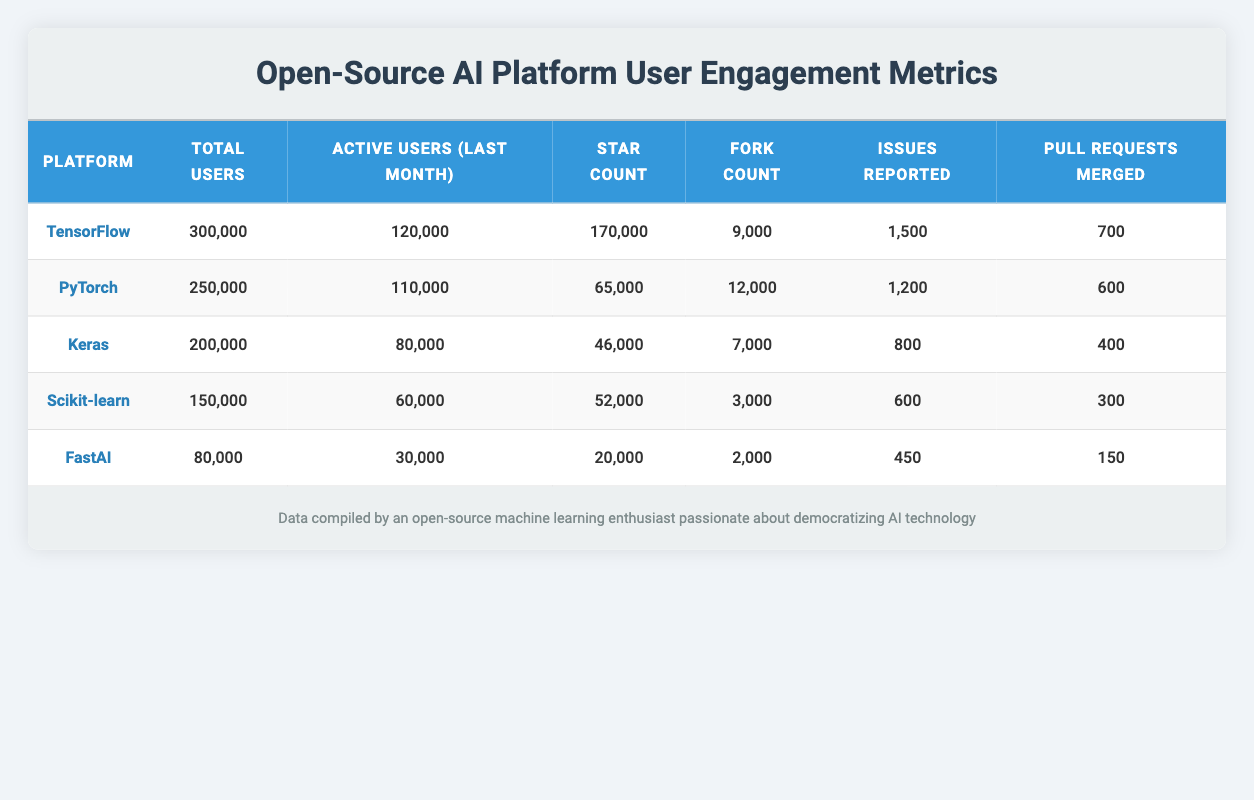What is the total number of users for Keras? According to the table, the row for Keras displays the total users as 200,000.
Answer: 200,000 Which platform has the highest star count? The table shows TensorFlow with a star count of 170,000, which is higher than other platforms, making it the highest.
Answer: TensorFlow What is the difference in active users between PyTorch and Scikit-learn? PyTorch has 110,000 active users, while Scikit-learn has 60,000. The difference is calculated as 110,000 - 60,000 = 50,000.
Answer: 50,000 How many pull requests merged are reported for FastAI? The table indicates that FastAI has 150 pull requests merged, mentioned directly in its row.
Answer: 150 Does Keras have more total users than PyTorch? The total users for Keras are 200,000, while for PyTorch, it is 250,000. Since 200,000 is less than 250,000, the answer is no.
Answer: No What is the average number of issues reported across all platforms? To find the average, first sum the issues reported: 1500 + 1200 + 800 + 600 + 450 = 3750. Then divide this total by the number of platforms (5), so 3750 / 5 = 750.
Answer: 750 How many platforms have more than 100,000 total users? The platforms TensorFlow (300,000), PyTorch (250,000), and Keras (200,000) have more than 100,000 total users. Thus, there are three platforms meeting this criterion.
Answer: 3 What is the ratio of active users to total users for Scikit-learn? For Scikit-learn, the active users are 60,000, and total users are 150,000. The ratio is 60,000 / 150,000, which simplifies to 2 / 5 or 0.4.
Answer: 0.4 Which platform reports the lowest number of issues? Looking at the issues reported, FastAI has the lowest count at 450 compared to all other platforms mentioned in the table.
Answer: FastAI 